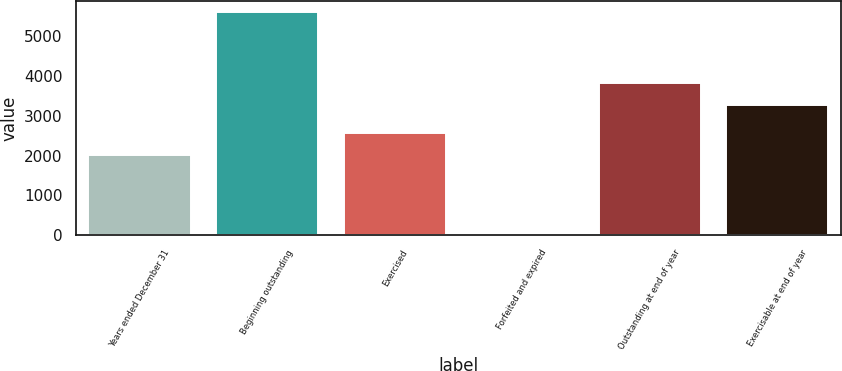Convert chart. <chart><loc_0><loc_0><loc_500><loc_500><bar_chart><fcel>Years ended December 31<fcel>Beginning outstanding<fcel>Exercised<fcel>Forfeited and expired<fcel>Outstanding at end of year<fcel>Exercisable at end of year<nl><fcel>2013<fcel>5611<fcel>2570.8<fcel>33<fcel>3827.8<fcel>3270<nl></chart> 